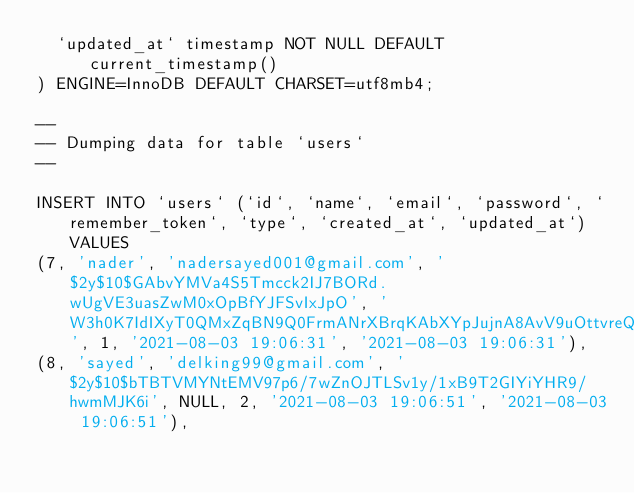Convert code to text. <code><loc_0><loc_0><loc_500><loc_500><_SQL_>  `updated_at` timestamp NOT NULL DEFAULT current_timestamp()
) ENGINE=InnoDB DEFAULT CHARSET=utf8mb4;

--
-- Dumping data for table `users`
--

INSERT INTO `users` (`id`, `name`, `email`, `password`, `remember_token`, `type`, `created_at`, `updated_at`) VALUES
(7, 'nader', 'nadersayed001@gmail.com', '$2y$10$GAbvYMVa4S5Tmcck2IJ7BORd.wUgVE3uasZwM0xOpBfYJFSvIxJpO', 'W3h0K7IdIXyT0QMxZqBN9Q0FrmANrXBrqKAbXYpJujnA8AvV9uOttvreQVcG', 1, '2021-08-03 19:06:31', '2021-08-03 19:06:31'),
(8, 'sayed', 'delking99@gmail.com', '$2y$10$bTBTVMYNtEMV97p6/7wZnOJTLSv1y/1xB9T2GIYiYHR9/hwmMJK6i', NULL, 2, '2021-08-03 19:06:51', '2021-08-03 19:06:51'),</code> 